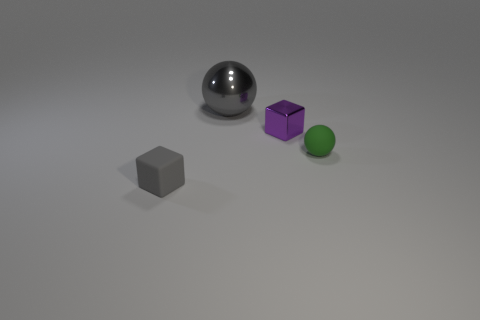What material is the green ball?
Provide a short and direct response. Rubber. There is a small cube that is in front of the tiny purple thing; what is its color?
Provide a short and direct response. Gray. How many small objects are gray objects or green rubber balls?
Offer a very short reply. 2. Does the rubber thing behind the small matte block have the same color as the shiny object in front of the large metal sphere?
Provide a short and direct response. No. How many other things are there of the same color as the large thing?
Offer a very short reply. 1. How many gray things are big shiny things or balls?
Give a very brief answer. 1. Does the tiny purple thing have the same shape as the gray object that is in front of the purple block?
Your answer should be compact. Yes. What is the shape of the green thing?
Ensure brevity in your answer.  Sphere. There is a purple object that is the same size as the gray matte thing; what material is it?
Offer a terse response. Metal. Are there any other things that have the same size as the gray metal ball?
Keep it short and to the point. No. 